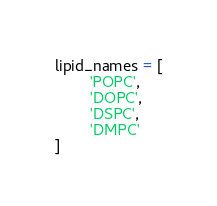<code> <loc_0><loc_0><loc_500><loc_500><_Python_>lipid_names = [
        'POPC',
        'DOPC',
        'DSPC',
        'DMPC'
]

</code> 